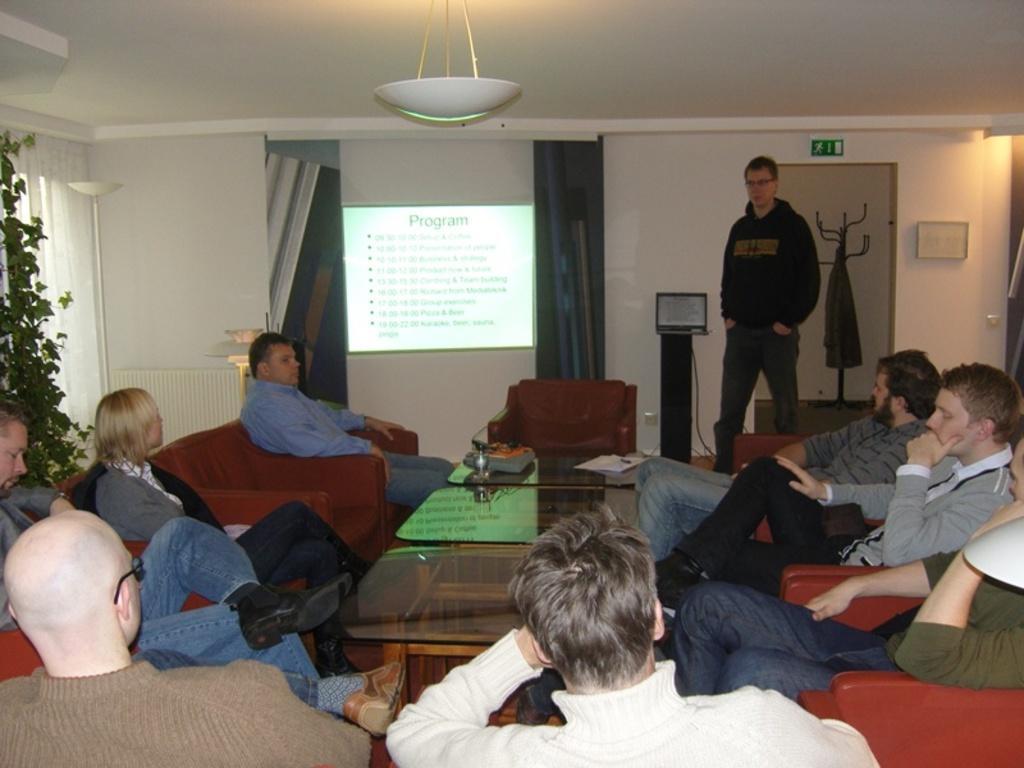Please provide a concise description of this image. In this picture we can see some people sitting on the sofas around the table and there is a who is standing in front of them and also there is a projector. 